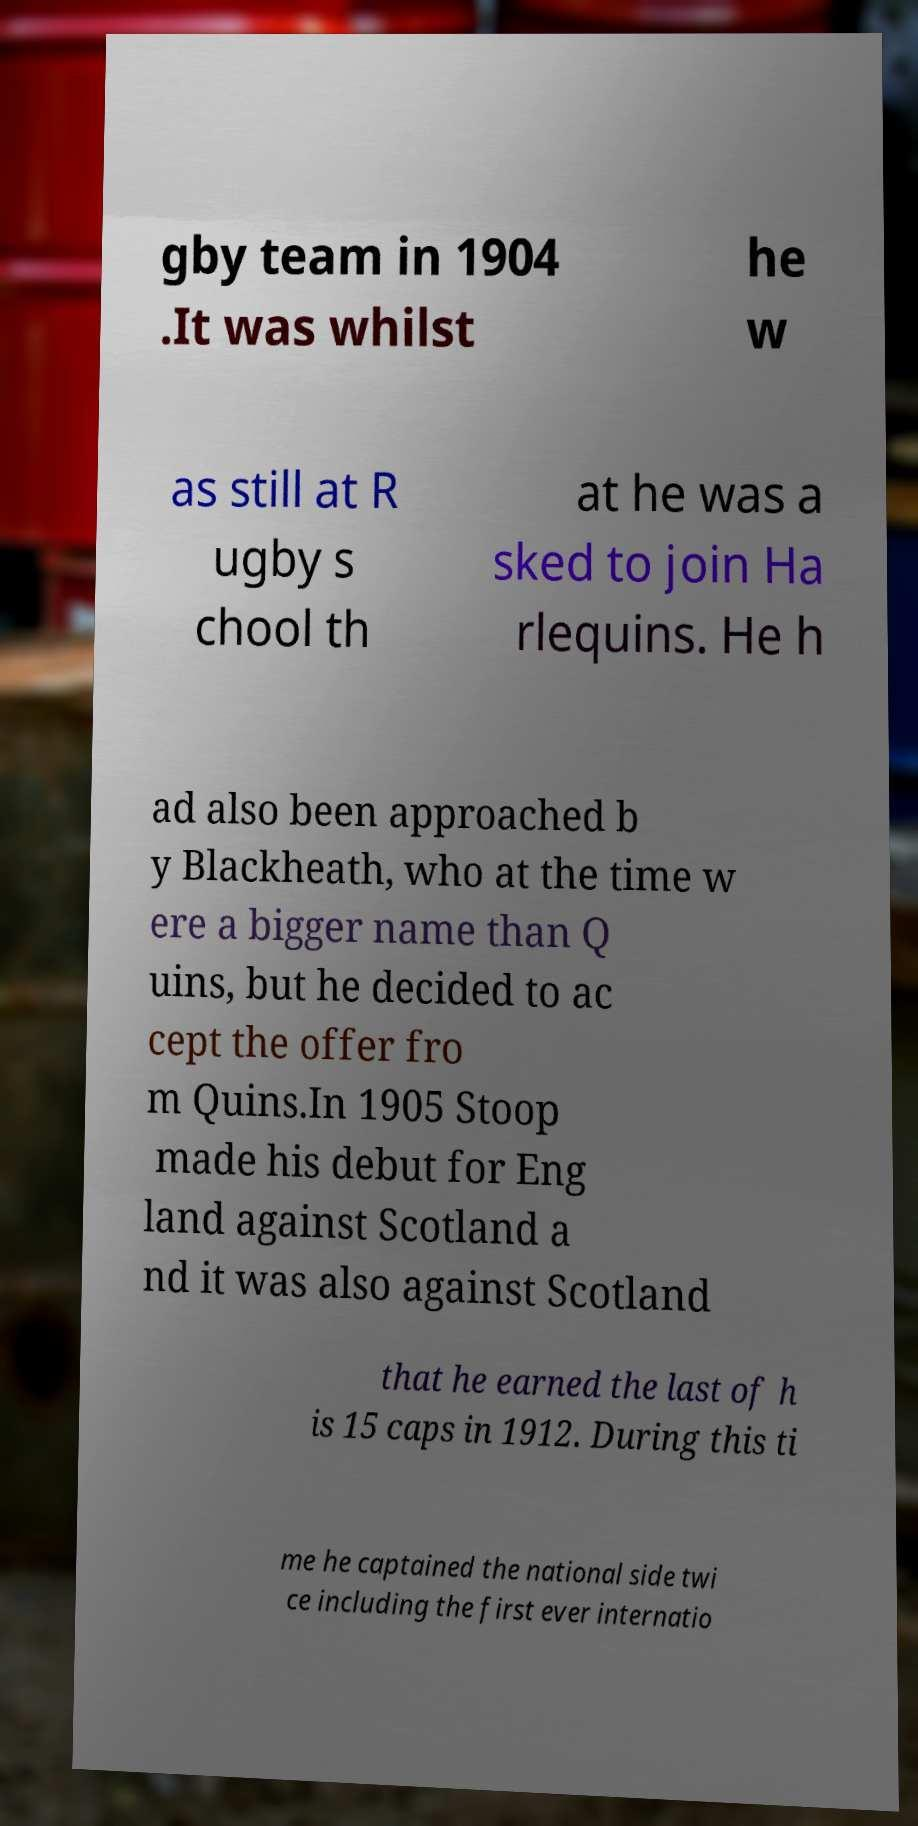Could you extract and type out the text from this image? gby team in 1904 .It was whilst he w as still at R ugby s chool th at he was a sked to join Ha rlequins. He h ad also been approached b y Blackheath, who at the time w ere a bigger name than Q uins, but he decided to ac cept the offer fro m Quins.In 1905 Stoop made his debut for Eng land against Scotland a nd it was also against Scotland that he earned the last of h is 15 caps in 1912. During this ti me he captained the national side twi ce including the first ever internatio 